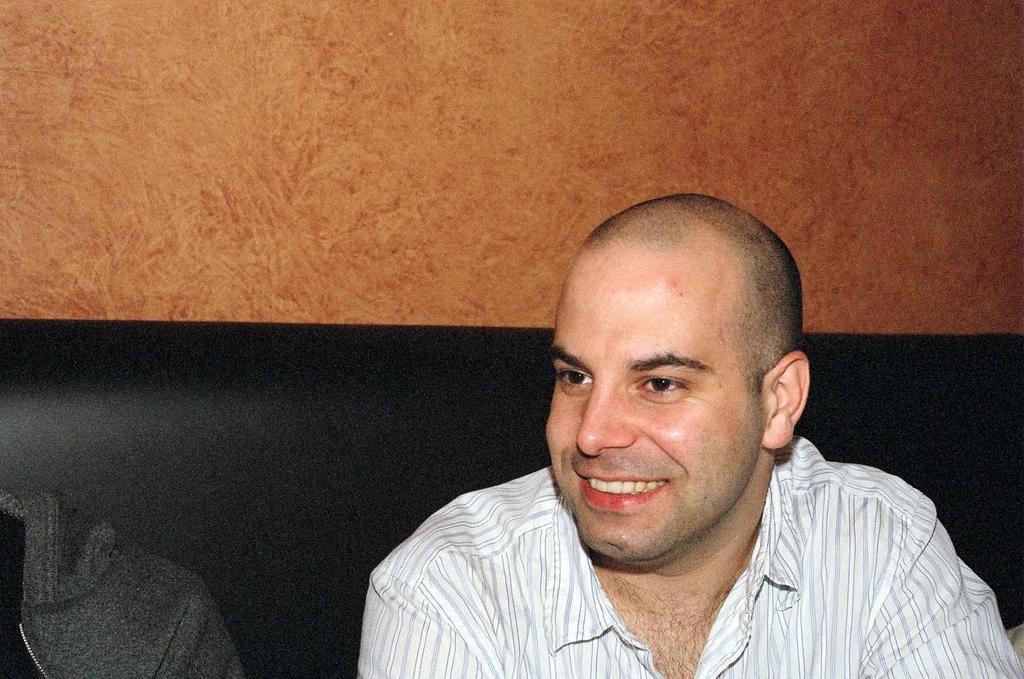Describe this image in one or two sentences. In this image I can see two people sitting on the couch. These people are wearing the white and grey color dresses. In the back I can see the brown color wall. 